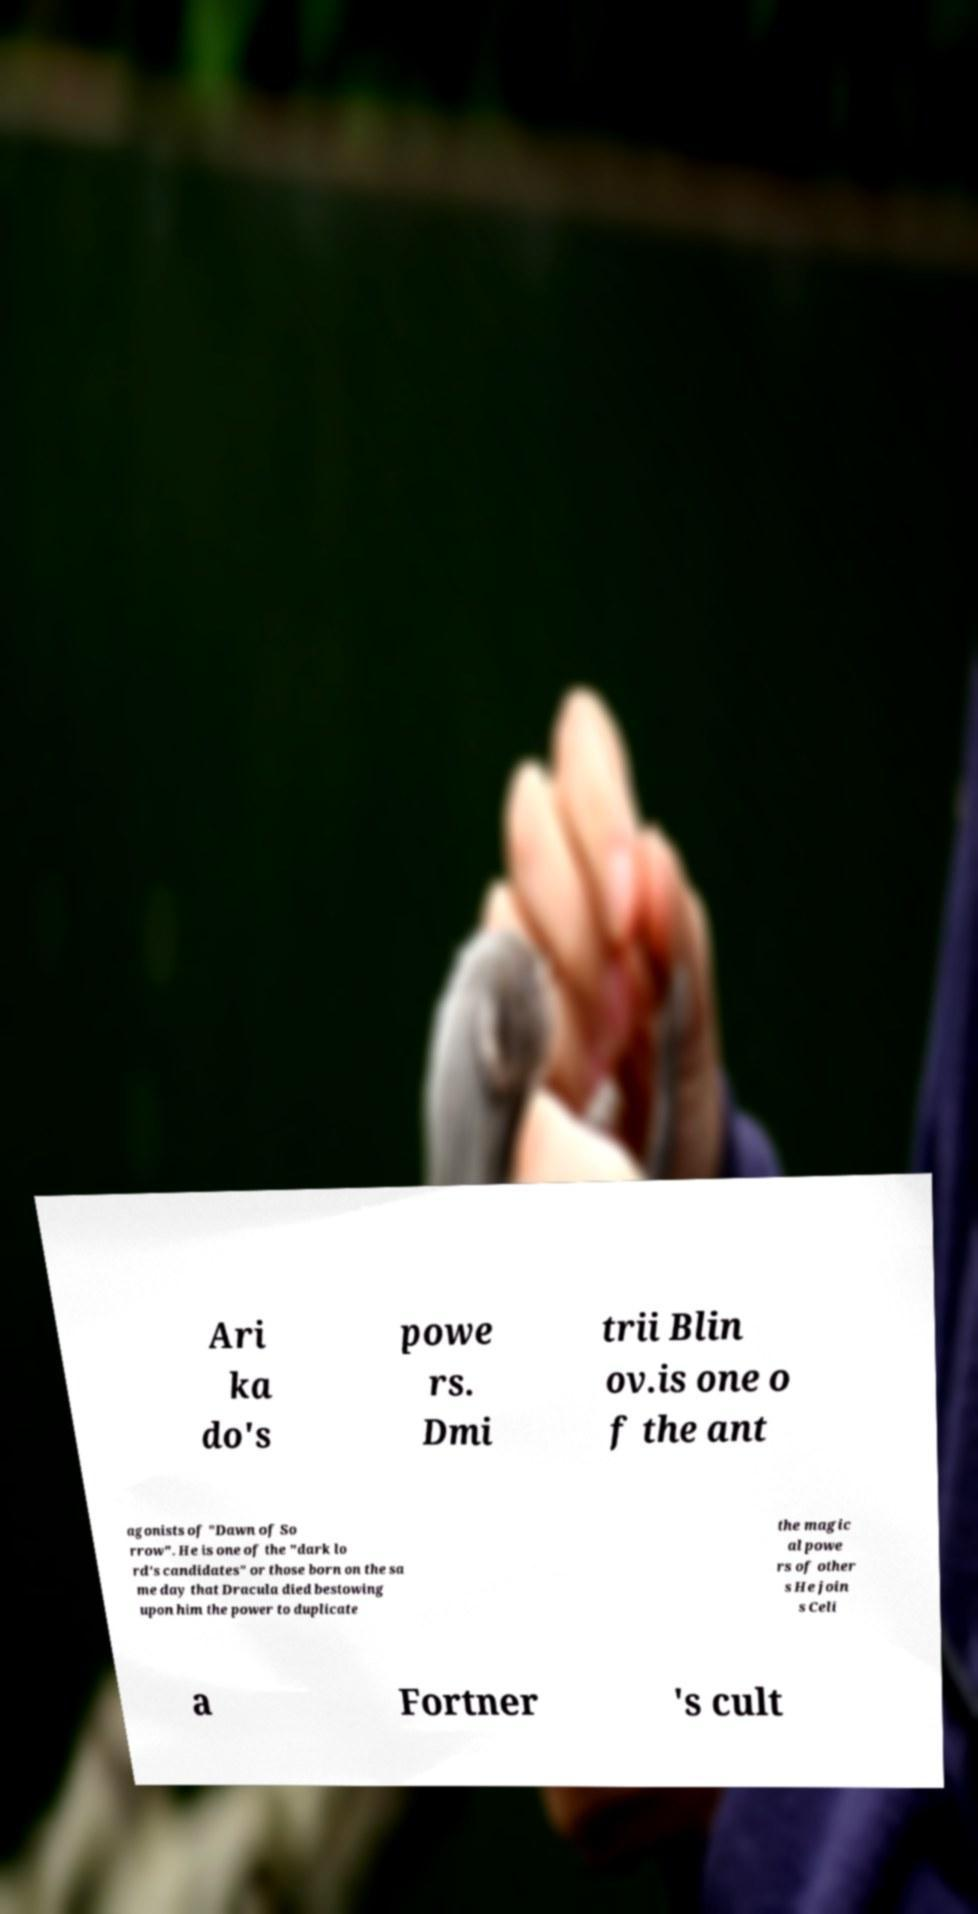Please identify and transcribe the text found in this image. Ari ka do's powe rs. Dmi trii Blin ov.is one o f the ant agonists of "Dawn of So rrow". He is one of the "dark lo rd's candidates" or those born on the sa me day that Dracula died bestowing upon him the power to duplicate the magic al powe rs of other s He join s Celi a Fortner 's cult 